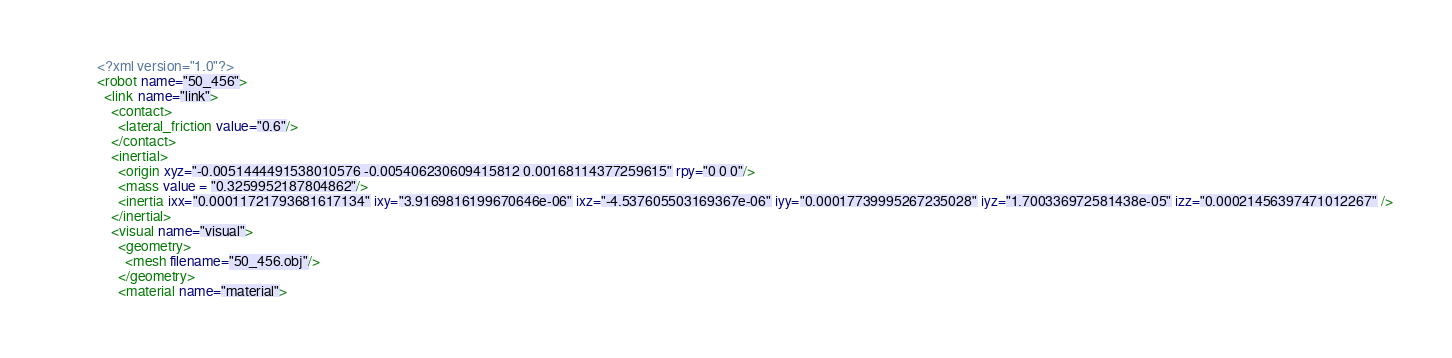Convert code to text. <code><loc_0><loc_0><loc_500><loc_500><_XML_><?xml version="1.0"?>
<robot name="50_456">
  <link name="link">
    <contact>
      <lateral_friction value="0.6"/>
    </contact>
    <inertial>
      <origin xyz="-0.0051444491538010576 -0.005406230609415812 0.00168114377259615" rpy="0 0 0"/>
      <mass value = "0.3259952187804862"/>
      <inertia ixx="0.00011721793681617134" ixy="3.9169816199670646e-06" ixz="-4.537605503169367e-06" iyy="0.00017739995267235028" iyz="1.700336972581438e-05" izz="0.00021456397471012267" />
    </inertial>
    <visual name="visual">
      <geometry>
        <mesh filename="50_456.obj"/>
      </geometry>
      <material name="material"></code> 